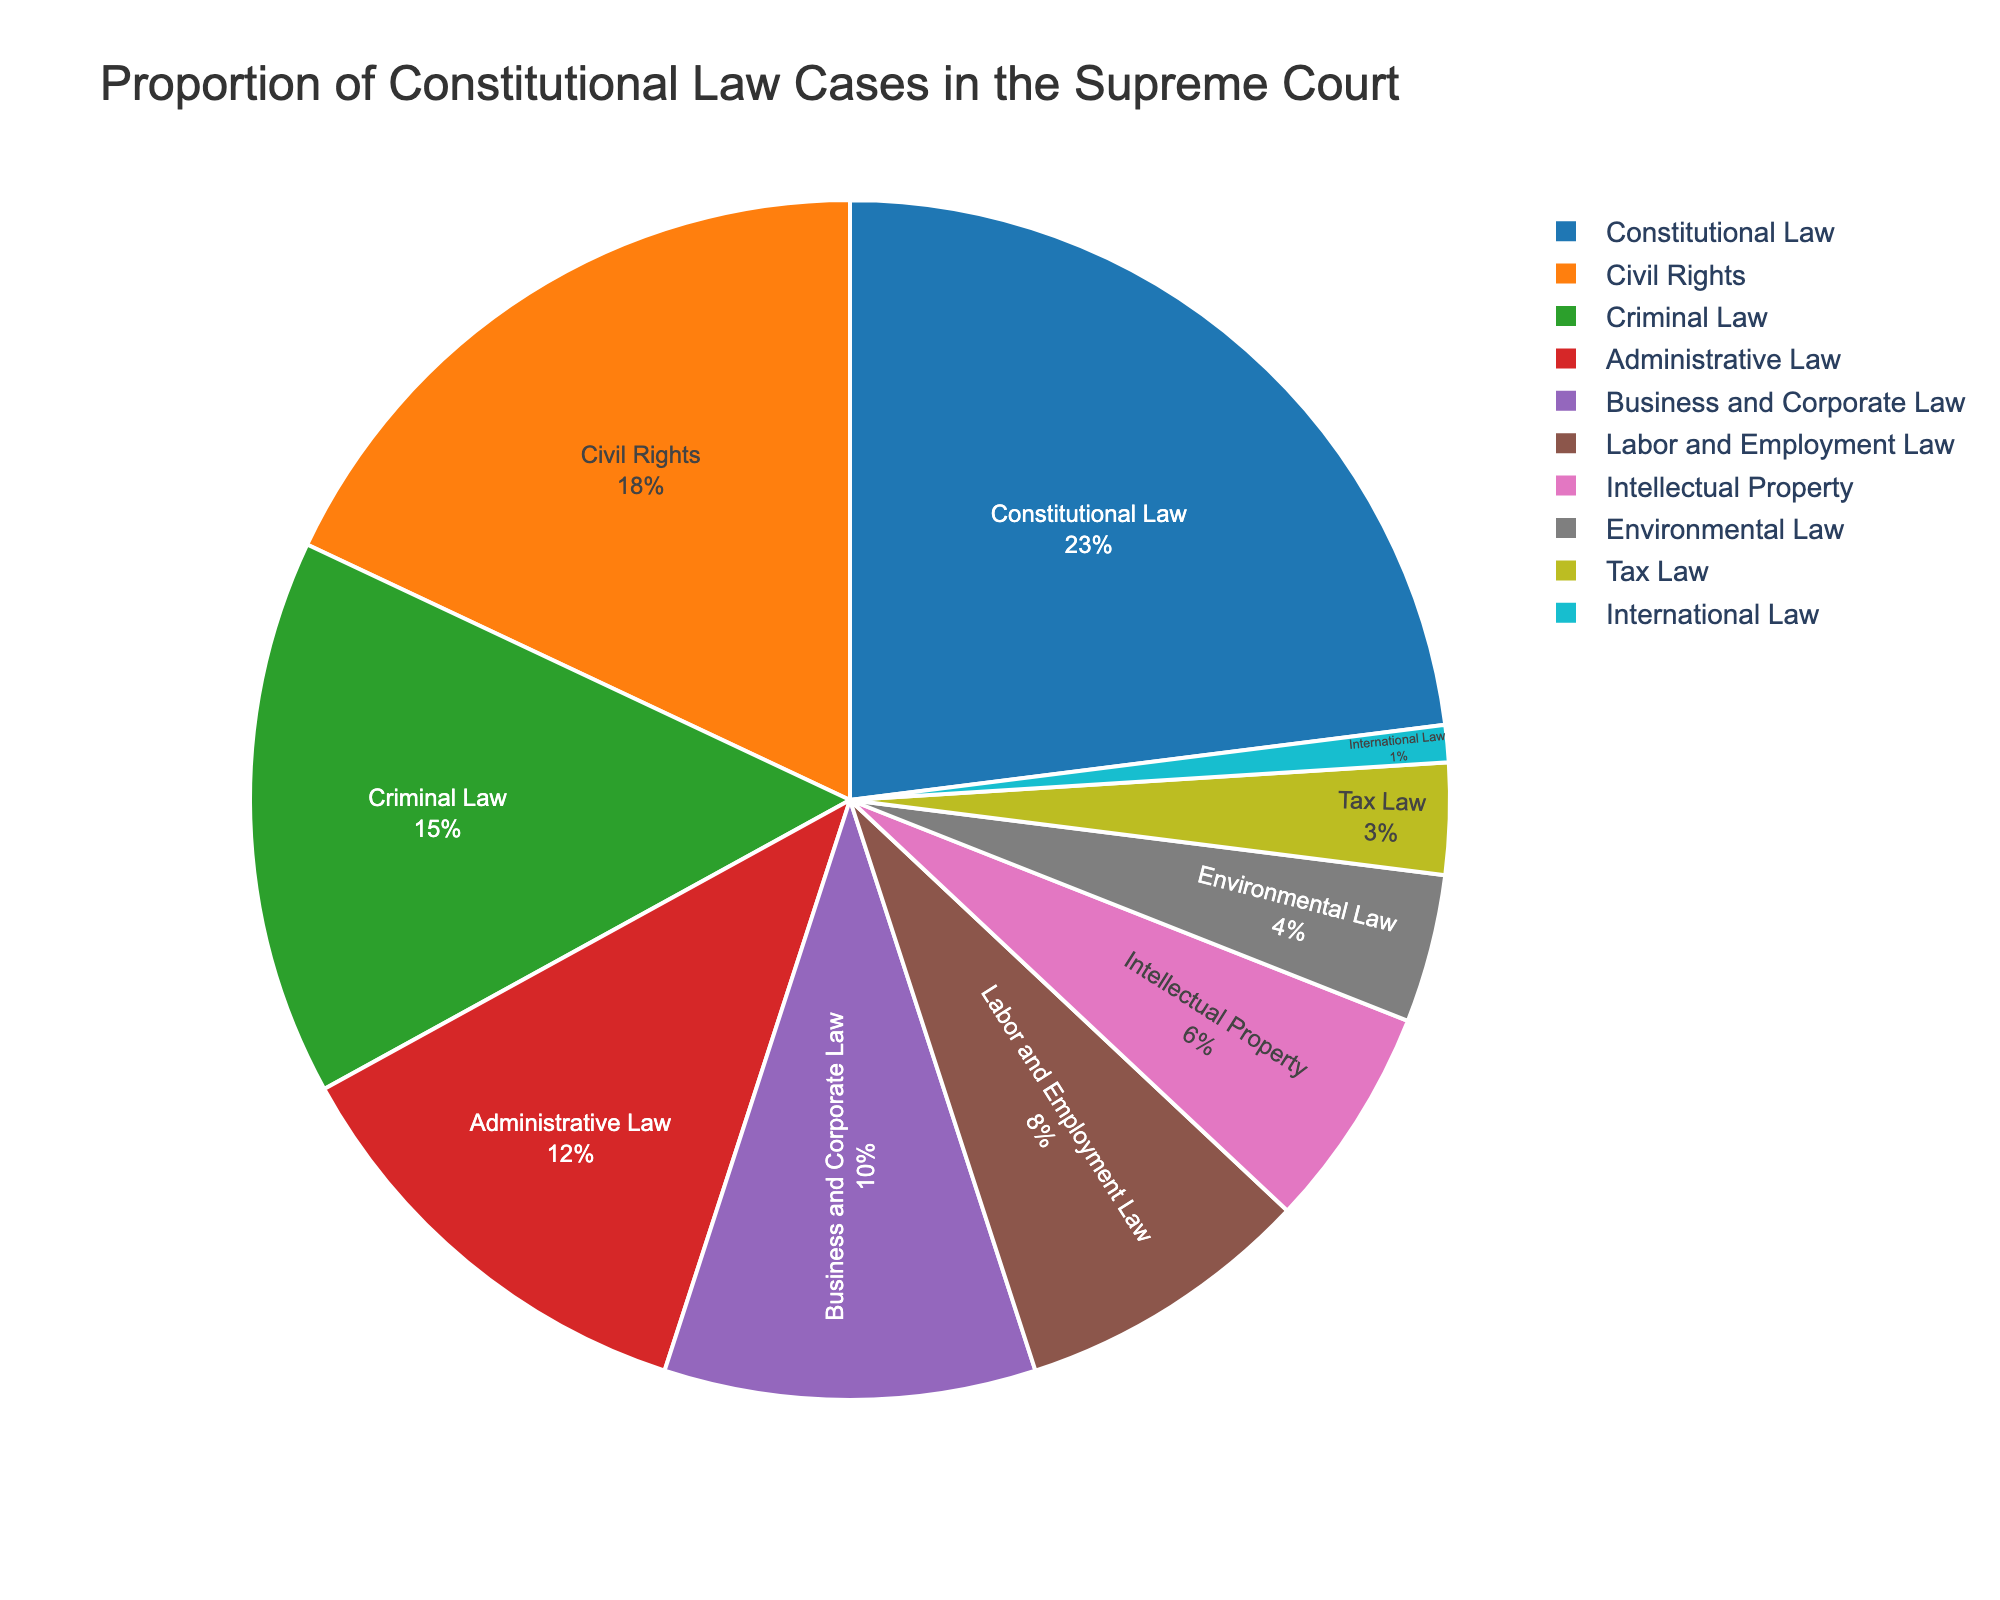What's the proportion of Constitutional Law cases heard by the Supreme Court? The segment labeled "Constitutional Law" shows a percentage value. By looking at the pie chart, we can identify the proportion represented by Constitutional Law cases.
Answer: 23% Which category has the second-largest proportion of cases? By observing the pie chart, identify the segment with the second-largest proportion after Constitutional Law cases. The "Civil Rights" segment comes next in size.
Answer: Civil Rights How does the proportion of Criminal Law cases compare to Business and Corporate Law cases? Examine the pie chart to find the percentage values for both Criminal Law and Business and Corporate Law segments. Compare these values to determine which is greater. Criminal Law has 15% and Business and Corporate Law has 10%. Therefore, Criminal Law has a larger proportion.
Answer: Criminal Law is greater What is the combined proportion of Civil Rights, Administrative Law, and Environmental Law cases? Locate the segments for Civil Rights (18%), Administrative Law (12%), and Environmental Law (4%) in the pie chart. Sum these percentages: 18 + 12 + 4 = 34%.
Answer: 34% Is the proportion of cases related to Labor and Employment Law higher than that of Intellectual Property cases? Identify the percentage values for Labor and Employment Law (8%) and Intellectual Property (6%) in the pie chart. Compare these values to see which is higher.
Answer: Yes, Labor and Employment Law is higher Which two categories make up the smallest combined proportion of cases? Through observation, find the two smallest segments in the pie chart. International Law (1%) and Tax Law (3%) are the two smallest categories. Their combined proportion is 1% + 3% = 4%.
Answer: International Law, Tax Law If you consider only Constitutional Law and the next three largest categories, what proportion of cases do they represent together? Identify the percentages for Constitutional Law (23%), Civil Rights (18%), Criminal Law (15%), and Administrative Law (12%). Sum these values: 23 + 18 + 15 + 12 = 68%.
Answer: 68% Which category has the lowest proportion of cases, and what is that proportion? Find the smallest segment in the pie chart. International Law is labeled with the smallest proportion, which is 1%.
Answer: International Law, 1% What is the difference in proportion between the highest and lowest categories? Identify the highest (Constitutional Law, 23%) and lowest (International Law, 1%) proportions from the chart. Calculate the difference: 23 - 1 = 22%.
Answer: 22% 